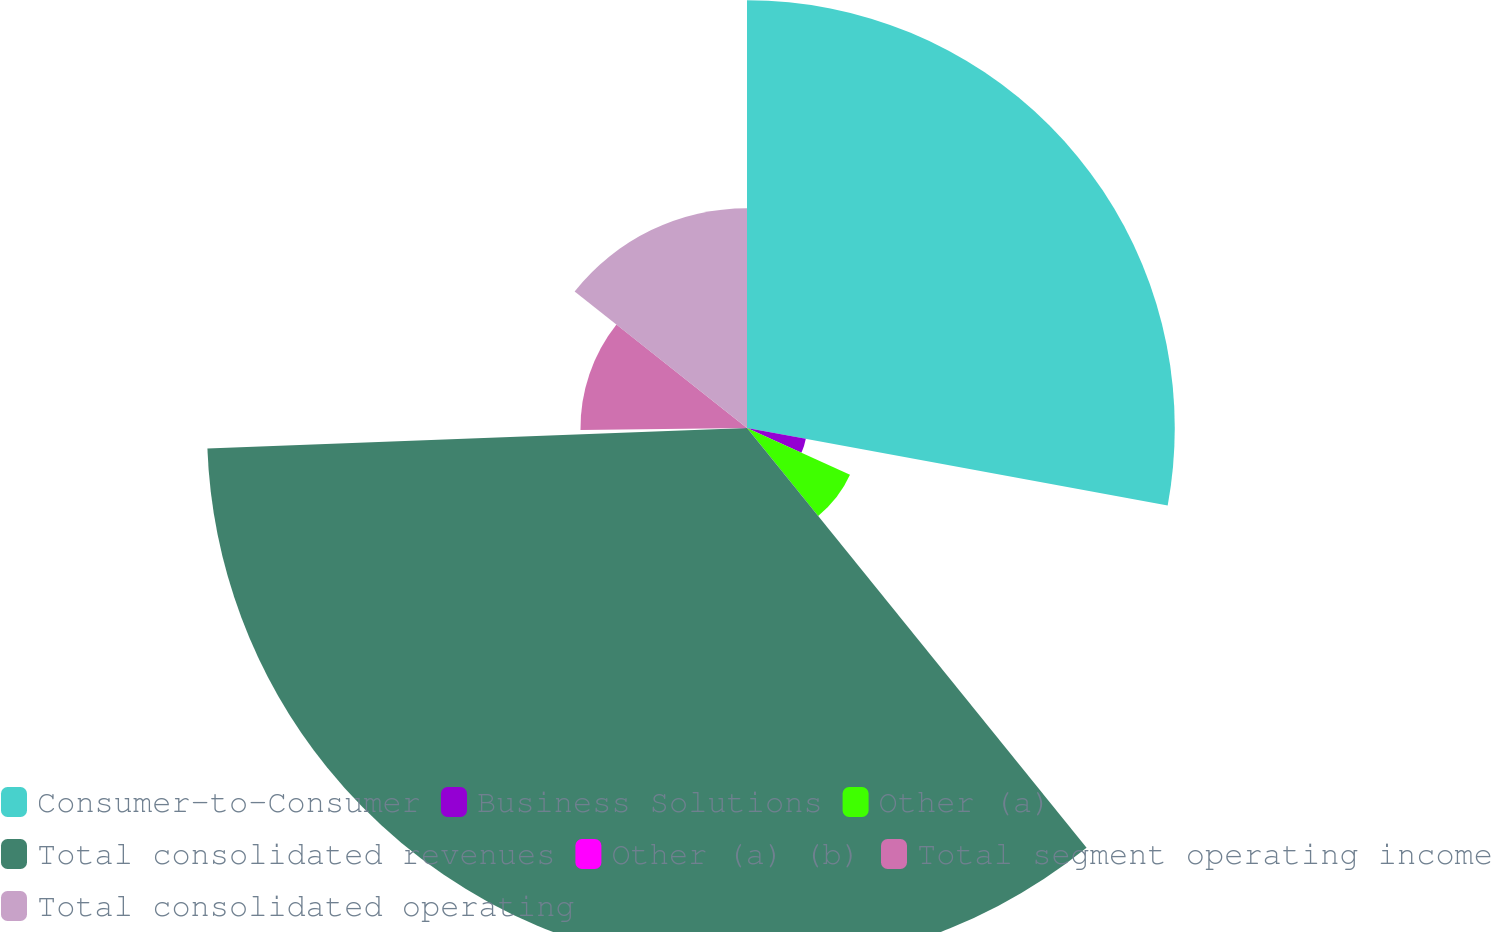Convert chart. <chart><loc_0><loc_0><loc_500><loc_500><pie_chart><fcel>Consumer-to-Consumer<fcel>Business Solutions<fcel>Other (a)<fcel>Total consolidated revenues<fcel>Other (a) (b)<fcel>Total segment operating income<fcel>Total consolidated operating<nl><fcel>27.9%<fcel>3.9%<fcel>7.38%<fcel>35.22%<fcel>0.41%<fcel>10.86%<fcel>14.34%<nl></chart> 